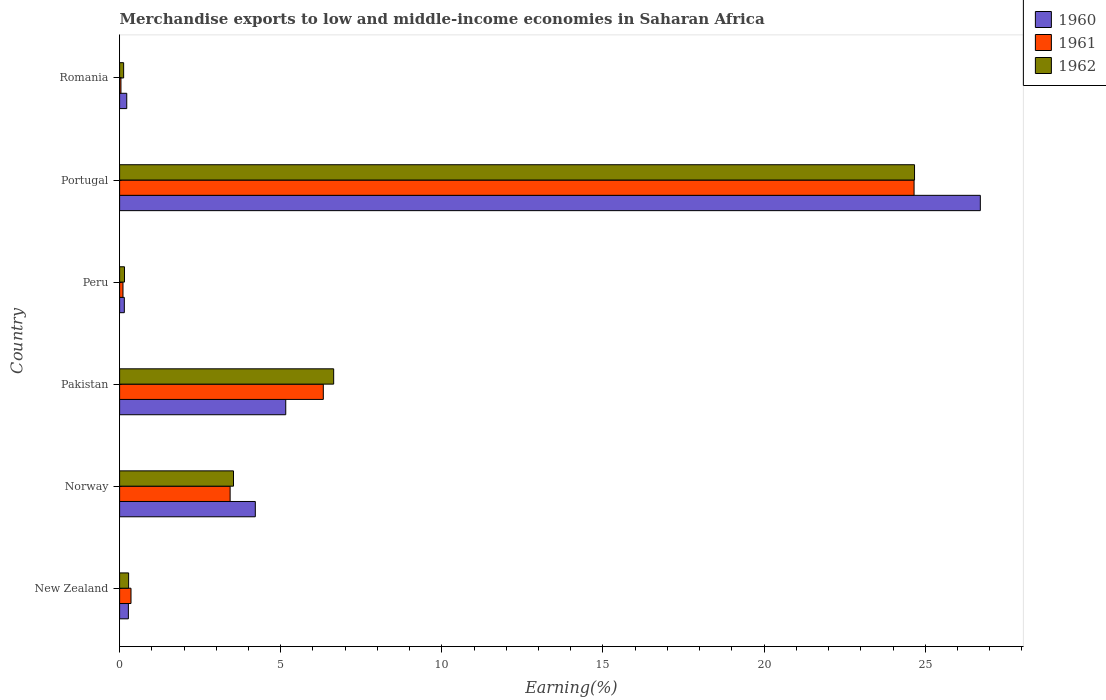How many different coloured bars are there?
Offer a terse response. 3. How many groups of bars are there?
Give a very brief answer. 6. Are the number of bars per tick equal to the number of legend labels?
Provide a short and direct response. Yes. Are the number of bars on each tick of the Y-axis equal?
Your response must be concise. Yes. What is the percentage of amount earned from merchandise exports in 1961 in Norway?
Your answer should be compact. 3.43. Across all countries, what is the maximum percentage of amount earned from merchandise exports in 1961?
Offer a very short reply. 24.65. Across all countries, what is the minimum percentage of amount earned from merchandise exports in 1960?
Make the answer very short. 0.15. What is the total percentage of amount earned from merchandise exports in 1960 in the graph?
Offer a very short reply. 36.72. What is the difference between the percentage of amount earned from merchandise exports in 1961 in Portugal and that in Romania?
Provide a succinct answer. 24.61. What is the difference between the percentage of amount earned from merchandise exports in 1960 in Peru and the percentage of amount earned from merchandise exports in 1961 in Portugal?
Offer a terse response. -24.51. What is the average percentage of amount earned from merchandise exports in 1960 per country?
Your answer should be compact. 6.12. What is the difference between the percentage of amount earned from merchandise exports in 1961 and percentage of amount earned from merchandise exports in 1962 in Romania?
Offer a very short reply. -0.08. What is the ratio of the percentage of amount earned from merchandise exports in 1962 in New Zealand to that in Norway?
Provide a succinct answer. 0.08. What is the difference between the highest and the second highest percentage of amount earned from merchandise exports in 1962?
Make the answer very short. 18.03. What is the difference between the highest and the lowest percentage of amount earned from merchandise exports in 1961?
Make the answer very short. 24.61. In how many countries, is the percentage of amount earned from merchandise exports in 1961 greater than the average percentage of amount earned from merchandise exports in 1961 taken over all countries?
Provide a short and direct response. 2. Is the sum of the percentage of amount earned from merchandise exports in 1960 in New Zealand and Romania greater than the maximum percentage of amount earned from merchandise exports in 1961 across all countries?
Provide a short and direct response. No. Is it the case that in every country, the sum of the percentage of amount earned from merchandise exports in 1961 and percentage of amount earned from merchandise exports in 1962 is greater than the percentage of amount earned from merchandise exports in 1960?
Give a very brief answer. No. How many bars are there?
Your response must be concise. 18. Are all the bars in the graph horizontal?
Give a very brief answer. Yes. Are the values on the major ticks of X-axis written in scientific E-notation?
Your answer should be very brief. No. Where does the legend appear in the graph?
Your response must be concise. Top right. What is the title of the graph?
Make the answer very short. Merchandise exports to low and middle-income economies in Saharan Africa. Does "1966" appear as one of the legend labels in the graph?
Your answer should be compact. No. What is the label or title of the X-axis?
Offer a very short reply. Earning(%). What is the Earning(%) in 1960 in New Zealand?
Offer a very short reply. 0.27. What is the Earning(%) in 1961 in New Zealand?
Give a very brief answer. 0.35. What is the Earning(%) in 1962 in New Zealand?
Offer a very short reply. 0.28. What is the Earning(%) in 1960 in Norway?
Make the answer very short. 4.21. What is the Earning(%) of 1961 in Norway?
Offer a very short reply. 3.43. What is the Earning(%) in 1962 in Norway?
Offer a terse response. 3.53. What is the Earning(%) of 1960 in Pakistan?
Make the answer very short. 5.16. What is the Earning(%) of 1961 in Pakistan?
Provide a short and direct response. 6.32. What is the Earning(%) in 1962 in Pakistan?
Ensure brevity in your answer.  6.64. What is the Earning(%) of 1960 in Peru?
Provide a short and direct response. 0.15. What is the Earning(%) in 1961 in Peru?
Provide a succinct answer. 0.1. What is the Earning(%) in 1962 in Peru?
Your answer should be very brief. 0.15. What is the Earning(%) of 1960 in Portugal?
Keep it short and to the point. 26.71. What is the Earning(%) in 1961 in Portugal?
Your answer should be compact. 24.65. What is the Earning(%) of 1962 in Portugal?
Provide a succinct answer. 24.67. What is the Earning(%) in 1960 in Romania?
Offer a very short reply. 0.22. What is the Earning(%) of 1961 in Romania?
Give a very brief answer. 0.04. What is the Earning(%) in 1962 in Romania?
Your answer should be very brief. 0.13. Across all countries, what is the maximum Earning(%) of 1960?
Ensure brevity in your answer.  26.71. Across all countries, what is the maximum Earning(%) of 1961?
Your answer should be compact. 24.65. Across all countries, what is the maximum Earning(%) of 1962?
Your answer should be very brief. 24.67. Across all countries, what is the minimum Earning(%) of 1960?
Provide a short and direct response. 0.15. Across all countries, what is the minimum Earning(%) of 1961?
Your response must be concise. 0.04. Across all countries, what is the minimum Earning(%) of 1962?
Make the answer very short. 0.13. What is the total Earning(%) of 1960 in the graph?
Your response must be concise. 36.72. What is the total Earning(%) of 1961 in the graph?
Give a very brief answer. 34.91. What is the total Earning(%) in 1962 in the graph?
Your answer should be compact. 35.4. What is the difference between the Earning(%) of 1960 in New Zealand and that in Norway?
Offer a terse response. -3.94. What is the difference between the Earning(%) in 1961 in New Zealand and that in Norway?
Make the answer very short. -3.08. What is the difference between the Earning(%) in 1962 in New Zealand and that in Norway?
Offer a terse response. -3.25. What is the difference between the Earning(%) in 1960 in New Zealand and that in Pakistan?
Give a very brief answer. -4.88. What is the difference between the Earning(%) of 1961 in New Zealand and that in Pakistan?
Offer a terse response. -5.97. What is the difference between the Earning(%) of 1962 in New Zealand and that in Pakistan?
Provide a short and direct response. -6.36. What is the difference between the Earning(%) in 1960 in New Zealand and that in Peru?
Make the answer very short. 0.13. What is the difference between the Earning(%) in 1961 in New Zealand and that in Peru?
Offer a very short reply. 0.25. What is the difference between the Earning(%) of 1962 in New Zealand and that in Peru?
Give a very brief answer. 0.13. What is the difference between the Earning(%) in 1960 in New Zealand and that in Portugal?
Your answer should be very brief. -26.44. What is the difference between the Earning(%) of 1961 in New Zealand and that in Portugal?
Your answer should be compact. -24.3. What is the difference between the Earning(%) of 1962 in New Zealand and that in Portugal?
Offer a very short reply. -24.39. What is the difference between the Earning(%) in 1960 in New Zealand and that in Romania?
Your answer should be very brief. 0.05. What is the difference between the Earning(%) in 1961 in New Zealand and that in Romania?
Keep it short and to the point. 0.31. What is the difference between the Earning(%) of 1962 in New Zealand and that in Romania?
Make the answer very short. 0.15. What is the difference between the Earning(%) of 1960 in Norway and that in Pakistan?
Keep it short and to the point. -0.94. What is the difference between the Earning(%) of 1961 in Norway and that in Pakistan?
Offer a very short reply. -2.89. What is the difference between the Earning(%) of 1962 in Norway and that in Pakistan?
Make the answer very short. -3.11. What is the difference between the Earning(%) of 1960 in Norway and that in Peru?
Provide a short and direct response. 4.06. What is the difference between the Earning(%) in 1961 in Norway and that in Peru?
Your response must be concise. 3.32. What is the difference between the Earning(%) in 1962 in Norway and that in Peru?
Offer a terse response. 3.38. What is the difference between the Earning(%) in 1960 in Norway and that in Portugal?
Your response must be concise. -22.5. What is the difference between the Earning(%) of 1961 in Norway and that in Portugal?
Make the answer very short. -21.22. What is the difference between the Earning(%) in 1962 in Norway and that in Portugal?
Make the answer very short. -21.13. What is the difference between the Earning(%) of 1960 in Norway and that in Romania?
Offer a terse response. 3.99. What is the difference between the Earning(%) in 1961 in Norway and that in Romania?
Keep it short and to the point. 3.39. What is the difference between the Earning(%) in 1962 in Norway and that in Romania?
Ensure brevity in your answer.  3.41. What is the difference between the Earning(%) in 1960 in Pakistan and that in Peru?
Make the answer very short. 5.01. What is the difference between the Earning(%) of 1961 in Pakistan and that in Peru?
Your answer should be compact. 6.22. What is the difference between the Earning(%) of 1962 in Pakistan and that in Peru?
Provide a short and direct response. 6.49. What is the difference between the Earning(%) of 1960 in Pakistan and that in Portugal?
Offer a terse response. -21.55. What is the difference between the Earning(%) in 1961 in Pakistan and that in Portugal?
Your answer should be compact. -18.33. What is the difference between the Earning(%) of 1962 in Pakistan and that in Portugal?
Give a very brief answer. -18.03. What is the difference between the Earning(%) in 1960 in Pakistan and that in Romania?
Your answer should be compact. 4.93. What is the difference between the Earning(%) in 1961 in Pakistan and that in Romania?
Give a very brief answer. 6.28. What is the difference between the Earning(%) in 1962 in Pakistan and that in Romania?
Your answer should be very brief. 6.52. What is the difference between the Earning(%) in 1960 in Peru and that in Portugal?
Offer a terse response. -26.56. What is the difference between the Earning(%) in 1961 in Peru and that in Portugal?
Provide a short and direct response. -24.55. What is the difference between the Earning(%) of 1962 in Peru and that in Portugal?
Offer a very short reply. -24.52. What is the difference between the Earning(%) of 1960 in Peru and that in Romania?
Make the answer very short. -0.07. What is the difference between the Earning(%) in 1961 in Peru and that in Romania?
Keep it short and to the point. 0.06. What is the difference between the Earning(%) in 1962 in Peru and that in Romania?
Your answer should be very brief. 0.03. What is the difference between the Earning(%) in 1960 in Portugal and that in Romania?
Your answer should be very brief. 26.49. What is the difference between the Earning(%) in 1961 in Portugal and that in Romania?
Ensure brevity in your answer.  24.61. What is the difference between the Earning(%) in 1962 in Portugal and that in Romania?
Offer a very short reply. 24.54. What is the difference between the Earning(%) of 1960 in New Zealand and the Earning(%) of 1961 in Norway?
Your answer should be very brief. -3.16. What is the difference between the Earning(%) of 1960 in New Zealand and the Earning(%) of 1962 in Norway?
Your answer should be very brief. -3.26. What is the difference between the Earning(%) of 1961 in New Zealand and the Earning(%) of 1962 in Norway?
Provide a succinct answer. -3.18. What is the difference between the Earning(%) of 1960 in New Zealand and the Earning(%) of 1961 in Pakistan?
Your response must be concise. -6.05. What is the difference between the Earning(%) of 1960 in New Zealand and the Earning(%) of 1962 in Pakistan?
Your answer should be very brief. -6.37. What is the difference between the Earning(%) of 1961 in New Zealand and the Earning(%) of 1962 in Pakistan?
Offer a very short reply. -6.29. What is the difference between the Earning(%) in 1960 in New Zealand and the Earning(%) in 1961 in Peru?
Offer a terse response. 0.17. What is the difference between the Earning(%) of 1960 in New Zealand and the Earning(%) of 1962 in Peru?
Offer a very short reply. 0.12. What is the difference between the Earning(%) of 1961 in New Zealand and the Earning(%) of 1962 in Peru?
Offer a terse response. 0.2. What is the difference between the Earning(%) in 1960 in New Zealand and the Earning(%) in 1961 in Portugal?
Keep it short and to the point. -24.38. What is the difference between the Earning(%) of 1960 in New Zealand and the Earning(%) of 1962 in Portugal?
Ensure brevity in your answer.  -24.4. What is the difference between the Earning(%) of 1961 in New Zealand and the Earning(%) of 1962 in Portugal?
Offer a terse response. -24.31. What is the difference between the Earning(%) of 1960 in New Zealand and the Earning(%) of 1961 in Romania?
Give a very brief answer. 0.23. What is the difference between the Earning(%) in 1960 in New Zealand and the Earning(%) in 1962 in Romania?
Offer a very short reply. 0.15. What is the difference between the Earning(%) in 1961 in New Zealand and the Earning(%) in 1962 in Romania?
Ensure brevity in your answer.  0.23. What is the difference between the Earning(%) in 1960 in Norway and the Earning(%) in 1961 in Pakistan?
Ensure brevity in your answer.  -2.11. What is the difference between the Earning(%) of 1960 in Norway and the Earning(%) of 1962 in Pakistan?
Offer a terse response. -2.43. What is the difference between the Earning(%) in 1961 in Norway and the Earning(%) in 1962 in Pakistan?
Offer a very short reply. -3.21. What is the difference between the Earning(%) of 1960 in Norway and the Earning(%) of 1961 in Peru?
Offer a terse response. 4.11. What is the difference between the Earning(%) in 1960 in Norway and the Earning(%) in 1962 in Peru?
Make the answer very short. 4.06. What is the difference between the Earning(%) of 1961 in Norway and the Earning(%) of 1962 in Peru?
Your response must be concise. 3.28. What is the difference between the Earning(%) of 1960 in Norway and the Earning(%) of 1961 in Portugal?
Provide a short and direct response. -20.44. What is the difference between the Earning(%) of 1960 in Norway and the Earning(%) of 1962 in Portugal?
Offer a terse response. -20.46. What is the difference between the Earning(%) in 1961 in Norway and the Earning(%) in 1962 in Portugal?
Provide a short and direct response. -21.24. What is the difference between the Earning(%) in 1960 in Norway and the Earning(%) in 1961 in Romania?
Ensure brevity in your answer.  4.17. What is the difference between the Earning(%) in 1960 in Norway and the Earning(%) in 1962 in Romania?
Offer a very short reply. 4.09. What is the difference between the Earning(%) in 1961 in Norway and the Earning(%) in 1962 in Romania?
Your response must be concise. 3.3. What is the difference between the Earning(%) of 1960 in Pakistan and the Earning(%) of 1961 in Peru?
Keep it short and to the point. 5.05. What is the difference between the Earning(%) of 1960 in Pakistan and the Earning(%) of 1962 in Peru?
Offer a terse response. 5. What is the difference between the Earning(%) of 1961 in Pakistan and the Earning(%) of 1962 in Peru?
Provide a short and direct response. 6.17. What is the difference between the Earning(%) in 1960 in Pakistan and the Earning(%) in 1961 in Portugal?
Ensure brevity in your answer.  -19.5. What is the difference between the Earning(%) in 1960 in Pakistan and the Earning(%) in 1962 in Portugal?
Your answer should be very brief. -19.51. What is the difference between the Earning(%) of 1961 in Pakistan and the Earning(%) of 1962 in Portugal?
Offer a very short reply. -18.35. What is the difference between the Earning(%) in 1960 in Pakistan and the Earning(%) in 1961 in Romania?
Offer a terse response. 5.11. What is the difference between the Earning(%) in 1960 in Pakistan and the Earning(%) in 1962 in Romania?
Provide a short and direct response. 5.03. What is the difference between the Earning(%) in 1961 in Pakistan and the Earning(%) in 1962 in Romania?
Offer a terse response. 6.2. What is the difference between the Earning(%) of 1960 in Peru and the Earning(%) of 1961 in Portugal?
Ensure brevity in your answer.  -24.51. What is the difference between the Earning(%) of 1960 in Peru and the Earning(%) of 1962 in Portugal?
Offer a very short reply. -24.52. What is the difference between the Earning(%) of 1961 in Peru and the Earning(%) of 1962 in Portugal?
Give a very brief answer. -24.56. What is the difference between the Earning(%) in 1960 in Peru and the Earning(%) in 1961 in Romania?
Your answer should be compact. 0.1. What is the difference between the Earning(%) in 1960 in Peru and the Earning(%) in 1962 in Romania?
Provide a short and direct response. 0.02. What is the difference between the Earning(%) of 1961 in Peru and the Earning(%) of 1962 in Romania?
Make the answer very short. -0.02. What is the difference between the Earning(%) in 1960 in Portugal and the Earning(%) in 1961 in Romania?
Offer a very short reply. 26.67. What is the difference between the Earning(%) of 1960 in Portugal and the Earning(%) of 1962 in Romania?
Offer a terse response. 26.58. What is the difference between the Earning(%) of 1961 in Portugal and the Earning(%) of 1962 in Romania?
Make the answer very short. 24.53. What is the average Earning(%) in 1960 per country?
Your answer should be compact. 6.12. What is the average Earning(%) in 1961 per country?
Make the answer very short. 5.82. What is the average Earning(%) of 1962 per country?
Your answer should be very brief. 5.9. What is the difference between the Earning(%) of 1960 and Earning(%) of 1961 in New Zealand?
Offer a terse response. -0.08. What is the difference between the Earning(%) in 1960 and Earning(%) in 1962 in New Zealand?
Your response must be concise. -0.01. What is the difference between the Earning(%) of 1961 and Earning(%) of 1962 in New Zealand?
Provide a short and direct response. 0.07. What is the difference between the Earning(%) of 1960 and Earning(%) of 1961 in Norway?
Provide a succinct answer. 0.78. What is the difference between the Earning(%) of 1960 and Earning(%) of 1962 in Norway?
Offer a very short reply. 0.68. What is the difference between the Earning(%) of 1961 and Earning(%) of 1962 in Norway?
Ensure brevity in your answer.  -0.1. What is the difference between the Earning(%) of 1960 and Earning(%) of 1961 in Pakistan?
Ensure brevity in your answer.  -1.17. What is the difference between the Earning(%) of 1960 and Earning(%) of 1962 in Pakistan?
Keep it short and to the point. -1.49. What is the difference between the Earning(%) in 1961 and Earning(%) in 1962 in Pakistan?
Offer a very short reply. -0.32. What is the difference between the Earning(%) in 1960 and Earning(%) in 1961 in Peru?
Ensure brevity in your answer.  0.04. What is the difference between the Earning(%) in 1960 and Earning(%) in 1962 in Peru?
Make the answer very short. -0.01. What is the difference between the Earning(%) in 1961 and Earning(%) in 1962 in Peru?
Your answer should be very brief. -0.05. What is the difference between the Earning(%) in 1960 and Earning(%) in 1961 in Portugal?
Your response must be concise. 2.06. What is the difference between the Earning(%) in 1960 and Earning(%) in 1962 in Portugal?
Offer a very short reply. 2.04. What is the difference between the Earning(%) of 1961 and Earning(%) of 1962 in Portugal?
Provide a succinct answer. -0.01. What is the difference between the Earning(%) in 1960 and Earning(%) in 1961 in Romania?
Ensure brevity in your answer.  0.18. What is the difference between the Earning(%) of 1960 and Earning(%) of 1962 in Romania?
Provide a succinct answer. 0.1. What is the difference between the Earning(%) of 1961 and Earning(%) of 1962 in Romania?
Ensure brevity in your answer.  -0.08. What is the ratio of the Earning(%) in 1960 in New Zealand to that in Norway?
Ensure brevity in your answer.  0.06. What is the ratio of the Earning(%) in 1961 in New Zealand to that in Norway?
Give a very brief answer. 0.1. What is the ratio of the Earning(%) of 1962 in New Zealand to that in Norway?
Give a very brief answer. 0.08. What is the ratio of the Earning(%) of 1960 in New Zealand to that in Pakistan?
Your response must be concise. 0.05. What is the ratio of the Earning(%) in 1961 in New Zealand to that in Pakistan?
Your answer should be very brief. 0.06. What is the ratio of the Earning(%) in 1962 in New Zealand to that in Pakistan?
Ensure brevity in your answer.  0.04. What is the ratio of the Earning(%) in 1960 in New Zealand to that in Peru?
Your response must be concise. 1.85. What is the ratio of the Earning(%) of 1961 in New Zealand to that in Peru?
Provide a short and direct response. 3.37. What is the ratio of the Earning(%) of 1962 in New Zealand to that in Peru?
Offer a very short reply. 1.84. What is the ratio of the Earning(%) in 1960 in New Zealand to that in Portugal?
Provide a succinct answer. 0.01. What is the ratio of the Earning(%) in 1961 in New Zealand to that in Portugal?
Give a very brief answer. 0.01. What is the ratio of the Earning(%) of 1962 in New Zealand to that in Portugal?
Ensure brevity in your answer.  0.01. What is the ratio of the Earning(%) of 1960 in New Zealand to that in Romania?
Give a very brief answer. 1.23. What is the ratio of the Earning(%) of 1961 in New Zealand to that in Romania?
Offer a terse response. 8.45. What is the ratio of the Earning(%) in 1962 in New Zealand to that in Romania?
Offer a terse response. 2.23. What is the ratio of the Earning(%) of 1960 in Norway to that in Pakistan?
Offer a very short reply. 0.82. What is the ratio of the Earning(%) of 1961 in Norway to that in Pakistan?
Your answer should be very brief. 0.54. What is the ratio of the Earning(%) of 1962 in Norway to that in Pakistan?
Keep it short and to the point. 0.53. What is the ratio of the Earning(%) of 1960 in Norway to that in Peru?
Give a very brief answer. 28.69. What is the ratio of the Earning(%) of 1961 in Norway to that in Peru?
Keep it short and to the point. 32.67. What is the ratio of the Earning(%) in 1962 in Norway to that in Peru?
Your answer should be very brief. 23.23. What is the ratio of the Earning(%) in 1960 in Norway to that in Portugal?
Offer a terse response. 0.16. What is the ratio of the Earning(%) of 1961 in Norway to that in Portugal?
Offer a very short reply. 0.14. What is the ratio of the Earning(%) of 1962 in Norway to that in Portugal?
Offer a terse response. 0.14. What is the ratio of the Earning(%) in 1960 in Norway to that in Romania?
Give a very brief answer. 19. What is the ratio of the Earning(%) of 1961 in Norway to that in Romania?
Offer a terse response. 81.93. What is the ratio of the Earning(%) of 1962 in Norway to that in Romania?
Give a very brief answer. 28.18. What is the ratio of the Earning(%) in 1960 in Pakistan to that in Peru?
Give a very brief answer. 35.13. What is the ratio of the Earning(%) of 1961 in Pakistan to that in Peru?
Make the answer very short. 60.22. What is the ratio of the Earning(%) in 1962 in Pakistan to that in Peru?
Give a very brief answer. 43.66. What is the ratio of the Earning(%) of 1960 in Pakistan to that in Portugal?
Provide a short and direct response. 0.19. What is the ratio of the Earning(%) of 1961 in Pakistan to that in Portugal?
Offer a terse response. 0.26. What is the ratio of the Earning(%) in 1962 in Pakistan to that in Portugal?
Ensure brevity in your answer.  0.27. What is the ratio of the Earning(%) in 1960 in Pakistan to that in Romania?
Offer a very short reply. 23.26. What is the ratio of the Earning(%) in 1961 in Pakistan to that in Romania?
Provide a succinct answer. 151. What is the ratio of the Earning(%) in 1962 in Pakistan to that in Romania?
Ensure brevity in your answer.  52.96. What is the ratio of the Earning(%) of 1960 in Peru to that in Portugal?
Your response must be concise. 0.01. What is the ratio of the Earning(%) of 1961 in Peru to that in Portugal?
Provide a succinct answer. 0. What is the ratio of the Earning(%) in 1962 in Peru to that in Portugal?
Your response must be concise. 0.01. What is the ratio of the Earning(%) in 1960 in Peru to that in Romania?
Give a very brief answer. 0.66. What is the ratio of the Earning(%) in 1961 in Peru to that in Romania?
Provide a succinct answer. 2.51. What is the ratio of the Earning(%) in 1962 in Peru to that in Romania?
Ensure brevity in your answer.  1.21. What is the ratio of the Earning(%) in 1960 in Portugal to that in Romania?
Ensure brevity in your answer.  120.48. What is the ratio of the Earning(%) in 1961 in Portugal to that in Romania?
Provide a short and direct response. 588.91. What is the ratio of the Earning(%) in 1962 in Portugal to that in Romania?
Your response must be concise. 196.67. What is the difference between the highest and the second highest Earning(%) of 1960?
Your answer should be very brief. 21.55. What is the difference between the highest and the second highest Earning(%) in 1961?
Offer a terse response. 18.33. What is the difference between the highest and the second highest Earning(%) of 1962?
Offer a terse response. 18.03. What is the difference between the highest and the lowest Earning(%) of 1960?
Give a very brief answer. 26.56. What is the difference between the highest and the lowest Earning(%) in 1961?
Give a very brief answer. 24.61. What is the difference between the highest and the lowest Earning(%) in 1962?
Provide a succinct answer. 24.54. 